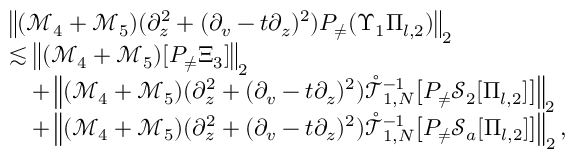<formula> <loc_0><loc_0><loc_500><loc_500>\begin{array} { r l } & { \left \| ( \mathcal { M } _ { 4 } + \mathcal { M } _ { 5 } ) ( \partial _ { z } ^ { 2 } + ( \partial _ { v } - t \partial _ { z } ) ^ { 2 } ) P _ { \neq } ( \Upsilon _ { 1 } \Pi _ { l , 2 } ) \right \| _ { 2 } } \\ & { \lesssim \left \| ( \mathcal { M } _ { 4 } + \mathcal { M } _ { 5 } ) [ P _ { \neq } \Xi _ { 3 } ] \right \| _ { 2 } } \\ & { \quad + \left \| ( \mathcal { M } _ { 4 } + \mathcal { M } _ { 5 } ) ( \partial _ { z } ^ { 2 } + ( \partial _ { v } - t \partial _ { z } ) ^ { 2 } ) \mathring { \mathcal { T } } _ { 1 , N } ^ { - 1 } \left [ P _ { \neq } \mathcal { S } _ { 2 } [ \Pi _ { l , 2 } ] \right ] \right \| _ { 2 } } \\ & { \quad + \left \| ( \mathcal { M } _ { 4 } + \mathcal { M } _ { 5 } ) ( \partial _ { z } ^ { 2 } + ( \partial _ { v } - t \partial _ { z } ) ^ { 2 } ) \mathring { \mathcal { T } } _ { 1 , N } ^ { - 1 } \left [ P _ { \neq } \mathcal { S } _ { a } [ \Pi _ { l , 2 } ] \right ] \right \| _ { 2 } , } \end{array}</formula> 